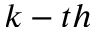<formula> <loc_0><loc_0><loc_500><loc_500>k - t h</formula> 